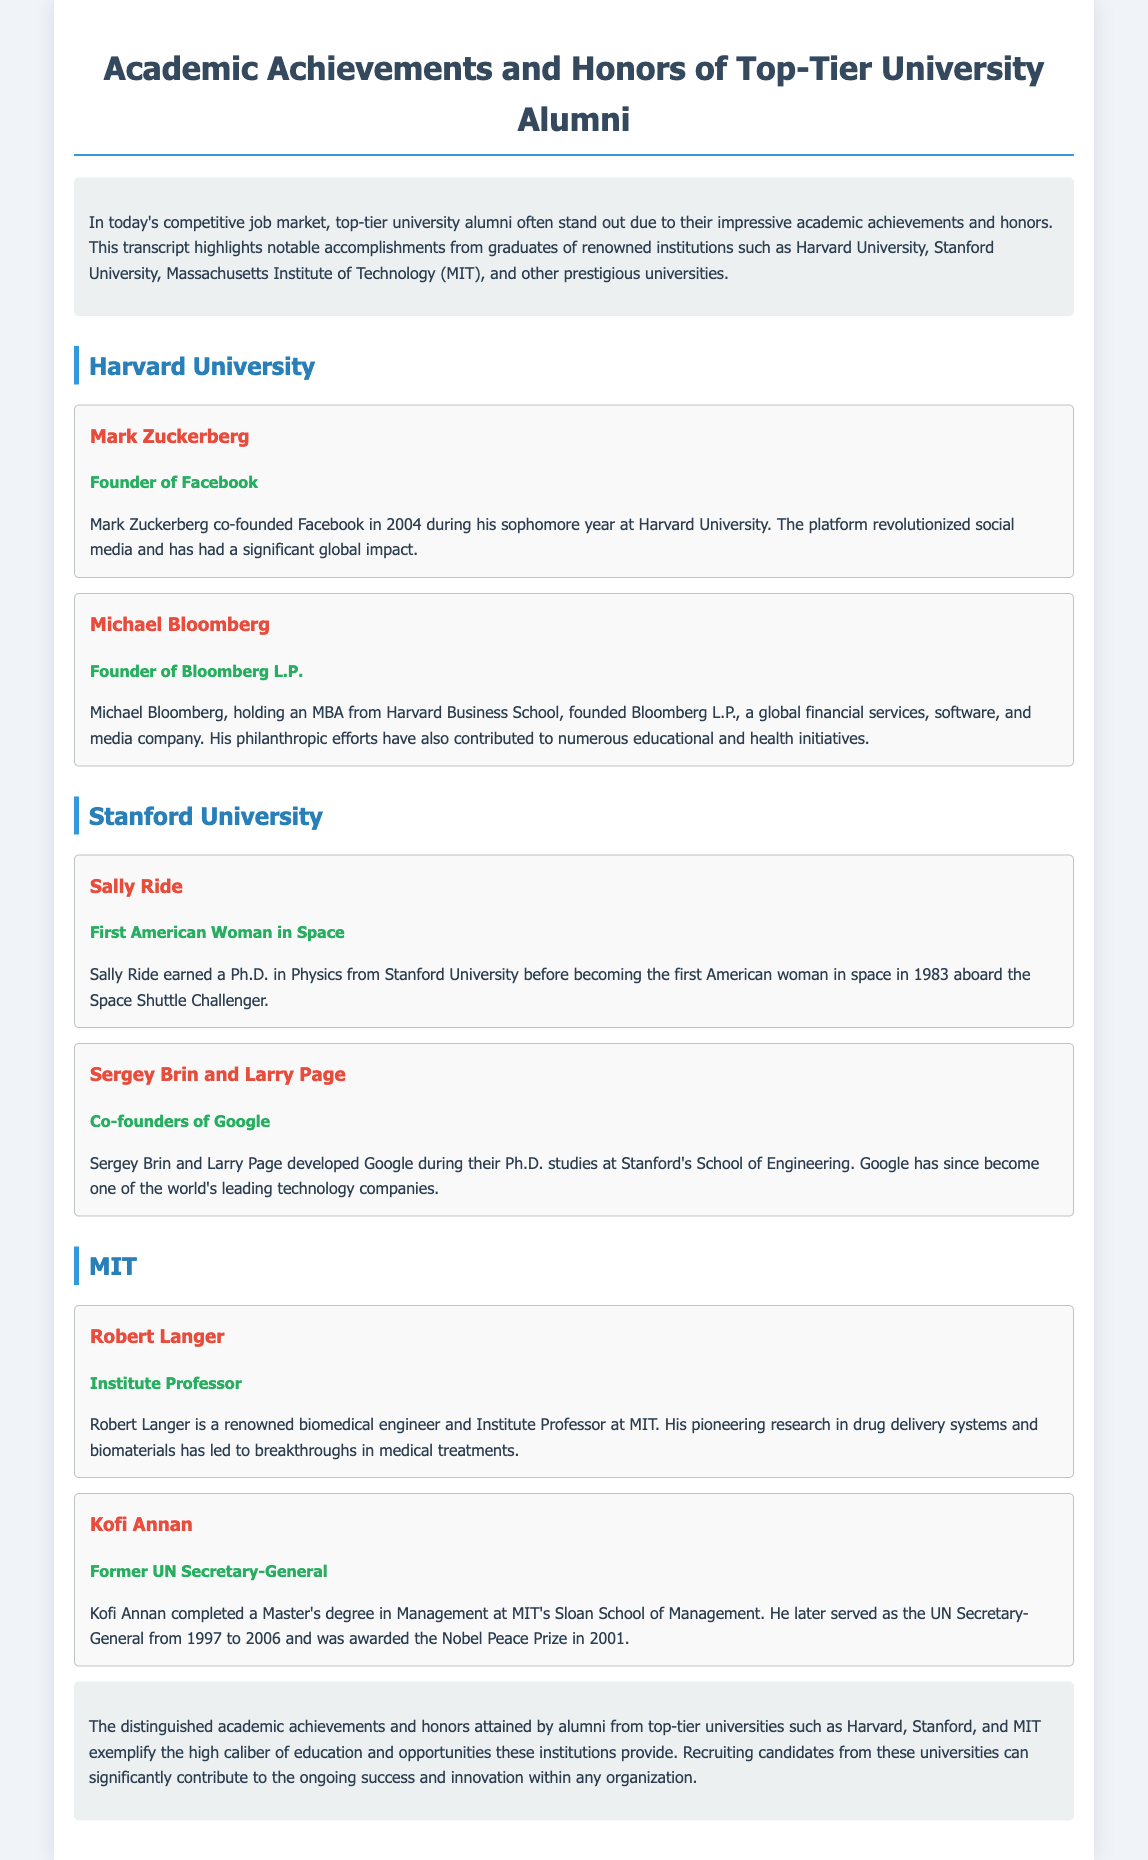What is the first honor listed under Harvard University? The first honor listed is that of Mark Zuckerberg, who is noted as the Founder of Facebook.
Answer: Founder of Facebook Who is the first American woman in space? Sally Ride is recognized as the first American woman in space according to the document.
Answer: Sally Ride Which company did Michael Bloomberg found? The document states that Michael Bloomberg founded Bloomberg L.P.
Answer: Bloomberg L.P How many individuals are named as co-founders of Google in the document? Sergey Brin and Larry Page are both named as co-founders, indicating there are two individuals.
Answer: Two What academic degree did Kofi Annan complete at MIT? Kofi Annan completed a Master's degree in Management at MIT's Sloan School of Management.
Answer: Master's degree in Management What is Robert Langer's profession? Robert Langer is described as a renowned biomedical engineer and Institute Professor at MIT.
Answer: Biomedical engineer How is the impact of university alumni characterized in the conclusion? The conclusion characterizes the impact of alumni as significant to the ongoing success and innovation within any organization.
Answer: Significant What was one of Sally Ride's academic achievements before her space mission? Sally Ride earned a Ph.D. in Physics from Stanford University before her achievement as an astronaut.
Answer: Ph.D. in Physics What notable prize did Kofi Annan receive during his lifetime? According to the document, Kofi Annan was awarded the Nobel Peace Prize in 2001.
Answer: Nobel Peace Prize 